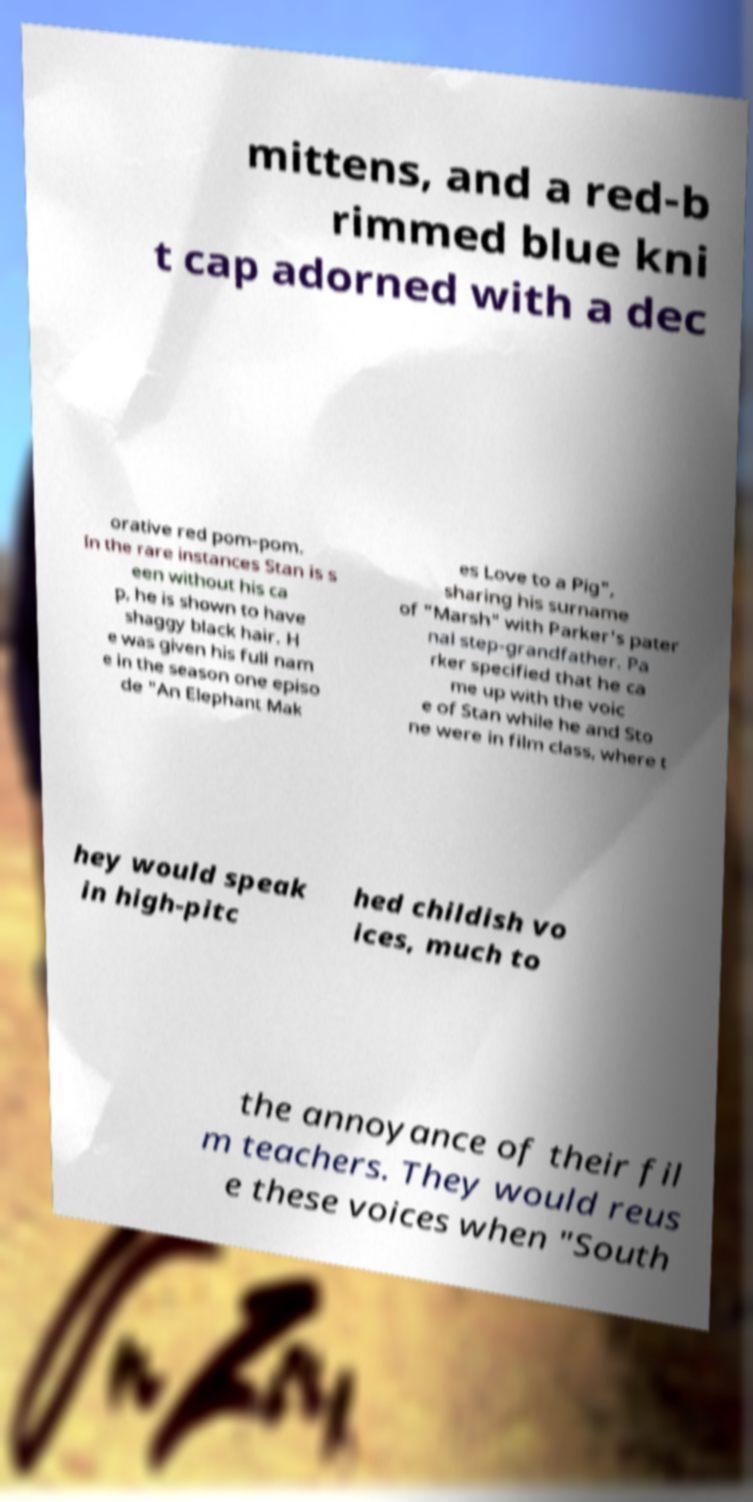Please read and relay the text visible in this image. What does it say? mittens, and a red-b rimmed blue kni t cap adorned with a dec orative red pom-pom. In the rare instances Stan is s een without his ca p, he is shown to have shaggy black hair. H e was given his full nam e in the season one episo de "An Elephant Mak es Love to a Pig", sharing his surname of "Marsh" with Parker's pater nal step-grandfather. Pa rker specified that he ca me up with the voic e of Stan while he and Sto ne were in film class, where t hey would speak in high-pitc hed childish vo ices, much to the annoyance of their fil m teachers. They would reus e these voices when "South 